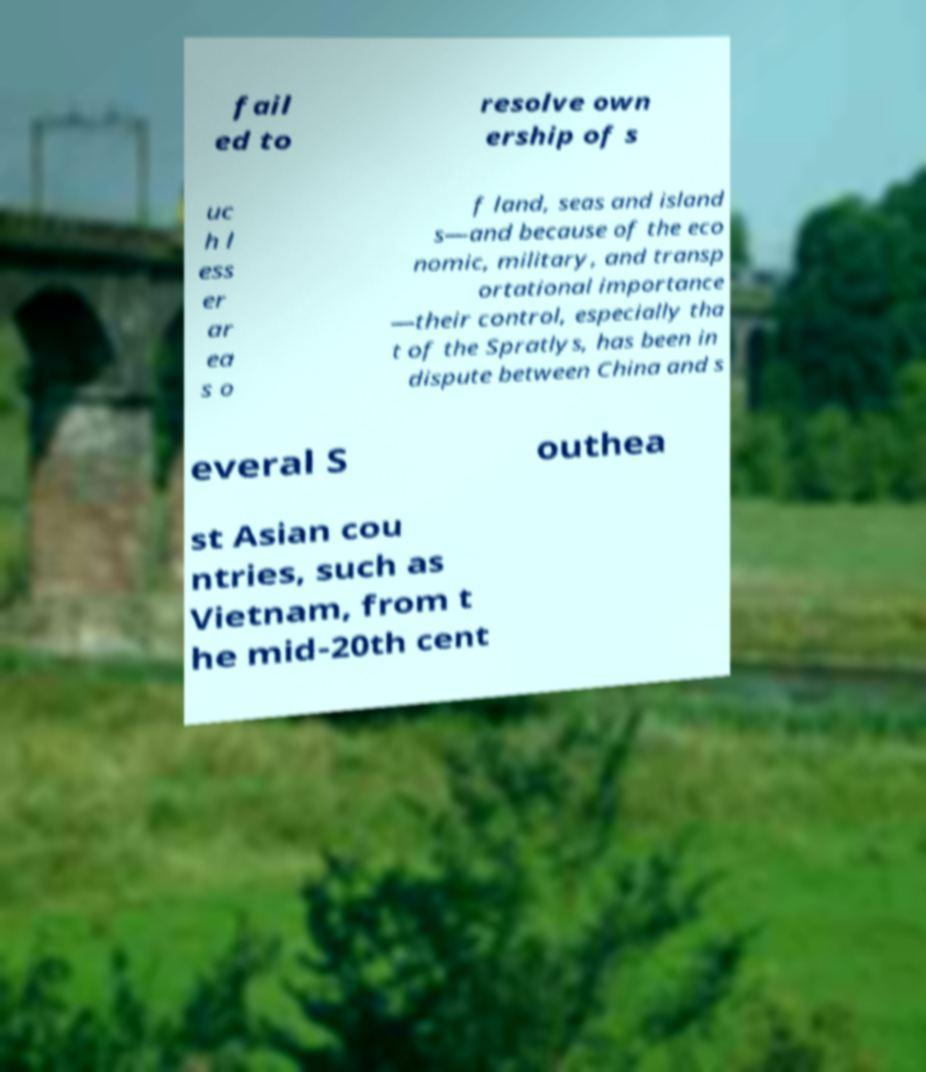Can you read and provide the text displayed in the image?This photo seems to have some interesting text. Can you extract and type it out for me? fail ed to resolve own ership of s uc h l ess er ar ea s o f land, seas and island s—and because of the eco nomic, military, and transp ortational importance —their control, especially tha t of the Spratlys, has been in dispute between China and s everal S outhea st Asian cou ntries, such as Vietnam, from t he mid-20th cent 